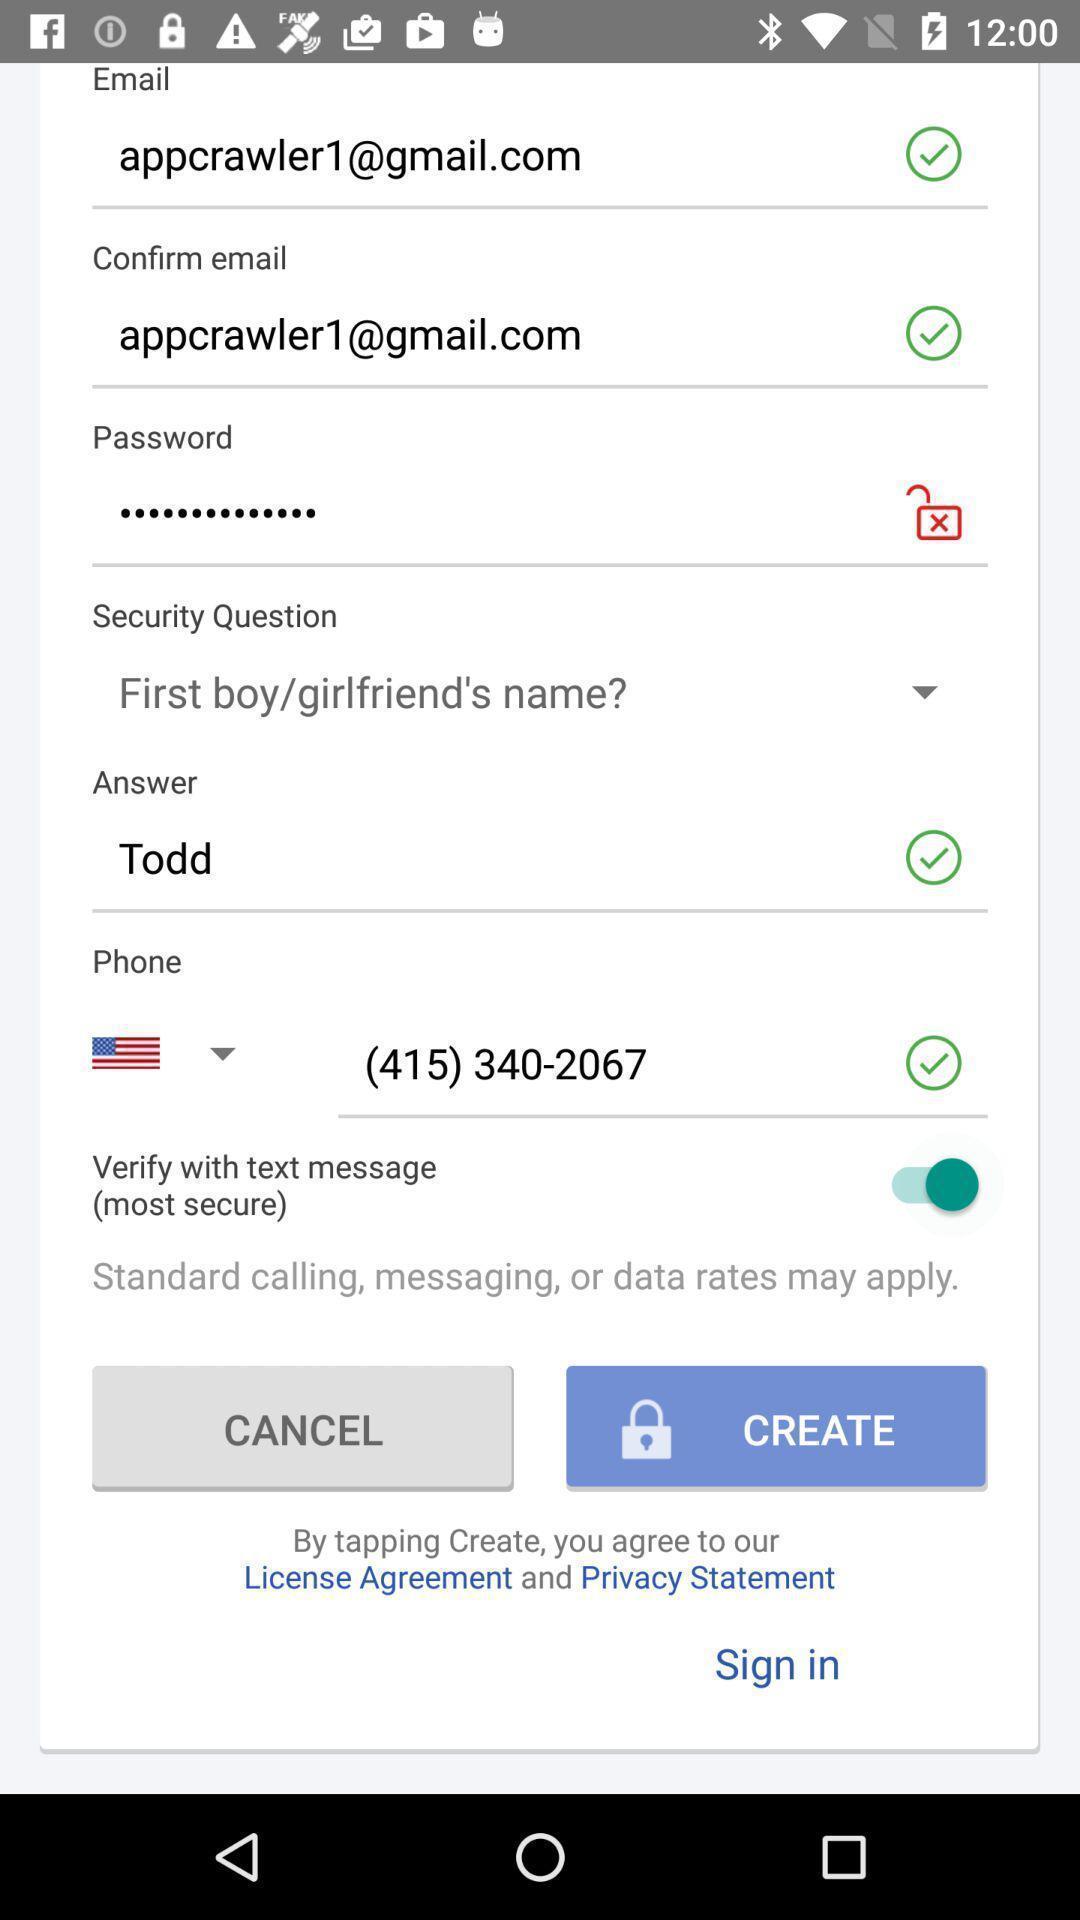Summarize the main components in this picture. Sign-in page for creating account on app. 